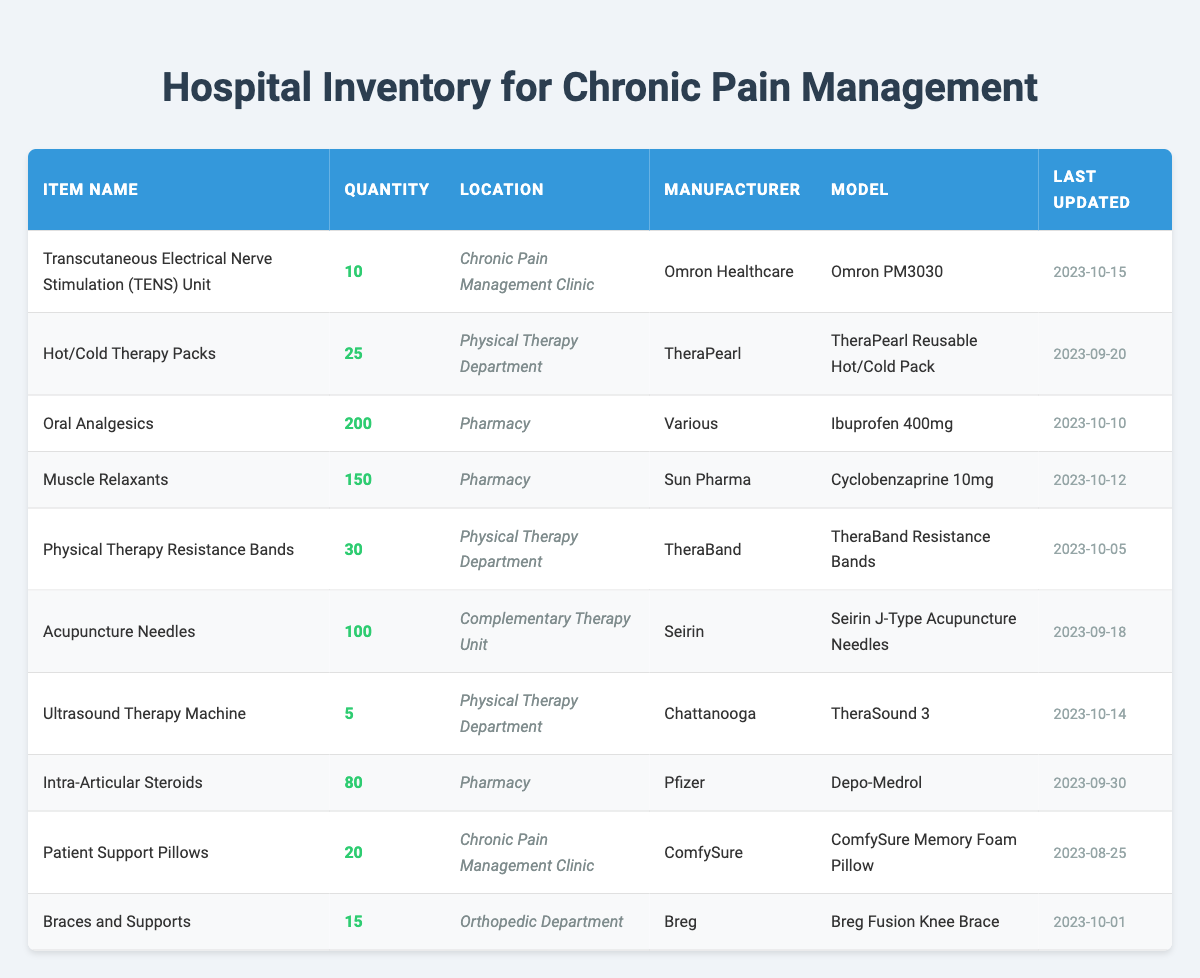What is the total quantity of Oral Analgesics available? The inventory shows that there are 200 units of Oral Analgesics listed. This value can be found directly under the quantity column for the item name "Oral Analgesics."
Answer: 200 How many more Hot/Cold Therapy Packs are there compared to Patient Support Pillows? There are 25 Hot/Cold Therapy Packs and 20 Patient Support Pillows. To find the difference, we subtract the quantity of Patient Support Pillows from the quantity of Hot/Cold Therapy Packs: 25 - 20 = 5.
Answer: 5 Are there more Muscle Relaxants or Intra-Articular Steroids in stock? There are 150 Muscle Relaxants and 80 Intra-Articular Steroids available. Since 150 is greater than 80, the answer is that there are more Muscle Relaxants.
Answer: Yes What is the total quantity of items in the Pharmacy? The Pharmacy has 3 items: Oral Analgesics (200), Muscle Relaxants (150), and Intra-Articular Steroids (80). To find the total, we sum these quantities: 200 + 150 + 80 = 430.
Answer: 430 Is the last update date for the TENS Unit later than the update date for Patient Support Pillows? The TENS Unit was last updated on 2023-10-15, while the Patient Support Pillows were last updated on 2023-08-25. Since 2023-10-15 is later than 2023-08-25, the answer is yes.
Answer: Yes What percentage of the total inventory does the TENS Unit represent? The total quantity of all items can be calculated as: 10 (TENS Unit) + 25 (Hot/Cold Therapy) + 200 (Oral Analgesics) + 150 (Muscle Relaxants) + 30 (Resistance Bands) + 100 (Acupuncture Needles) + 5 (Ultrasound Machine) + 80 (Steroids) + 20 (Pillows) + 15 (Braces) = 610. Then we find the percentage for TENS Units: (10 / 610) * 100 = approximately 1.64%.
Answer: 1.64% How many items in total are stored in the Physical Therapy Department? The Physical Therapy Department has 3 items listed: Hot/Cold Therapy Packs (25), Physical Therapy Resistance Bands (30), and Ultrasound Therapy Machine (5). To find the total, we sum these quantities: 25 + 30 + 5 = 60.
Answer: 60 Which item has the highest quantity and what is that quantity? The item with the highest quantity is Oral Analgesics, with a total of 200 units. This can be seen by comparing the quantities listed in the table.
Answer: Oral Analgesics, 200 